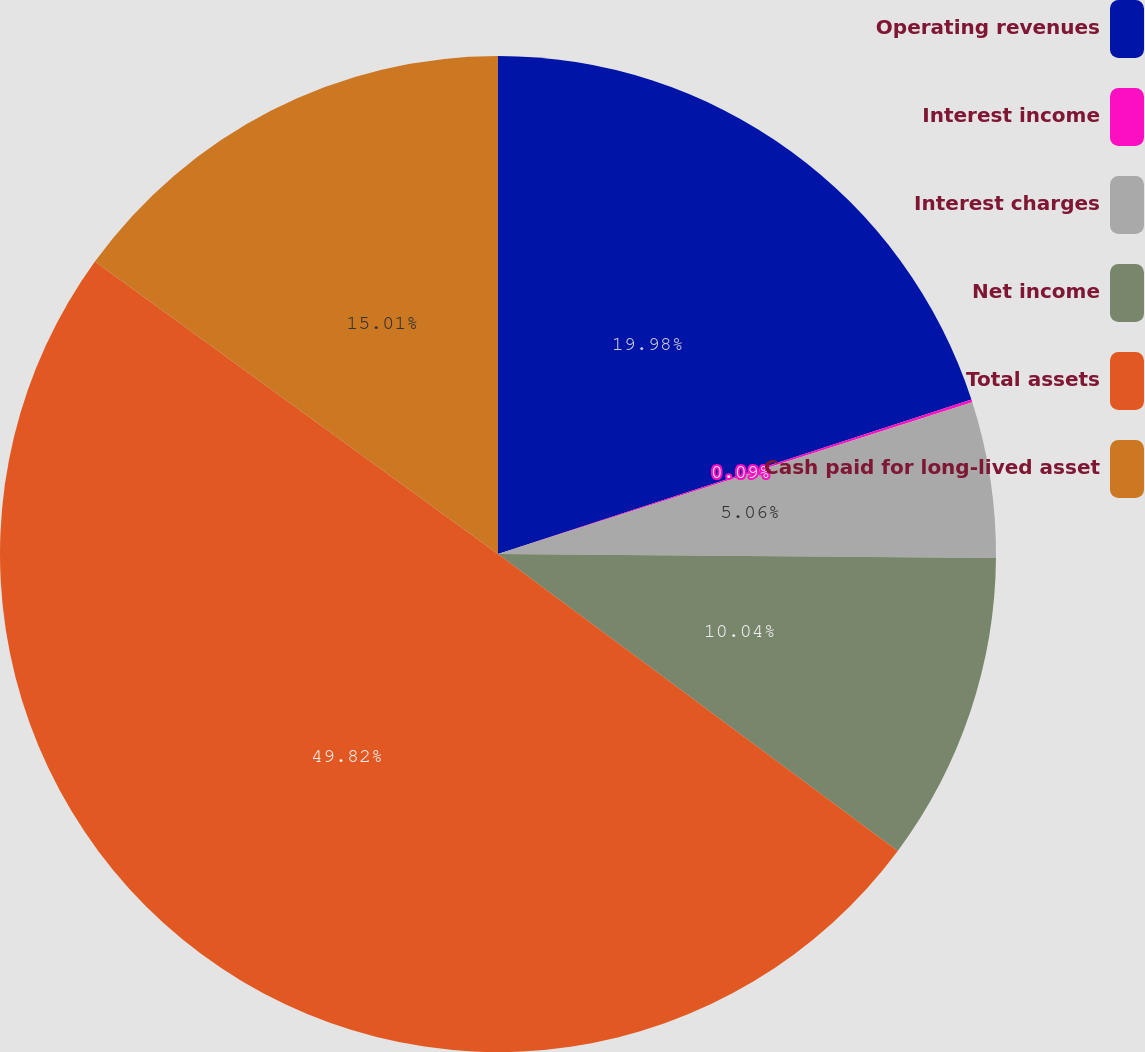<chart> <loc_0><loc_0><loc_500><loc_500><pie_chart><fcel>Operating revenues<fcel>Interest income<fcel>Interest charges<fcel>Net income<fcel>Total assets<fcel>Cash paid for long-lived asset<nl><fcel>19.98%<fcel>0.09%<fcel>5.06%<fcel>10.04%<fcel>49.82%<fcel>15.01%<nl></chart> 